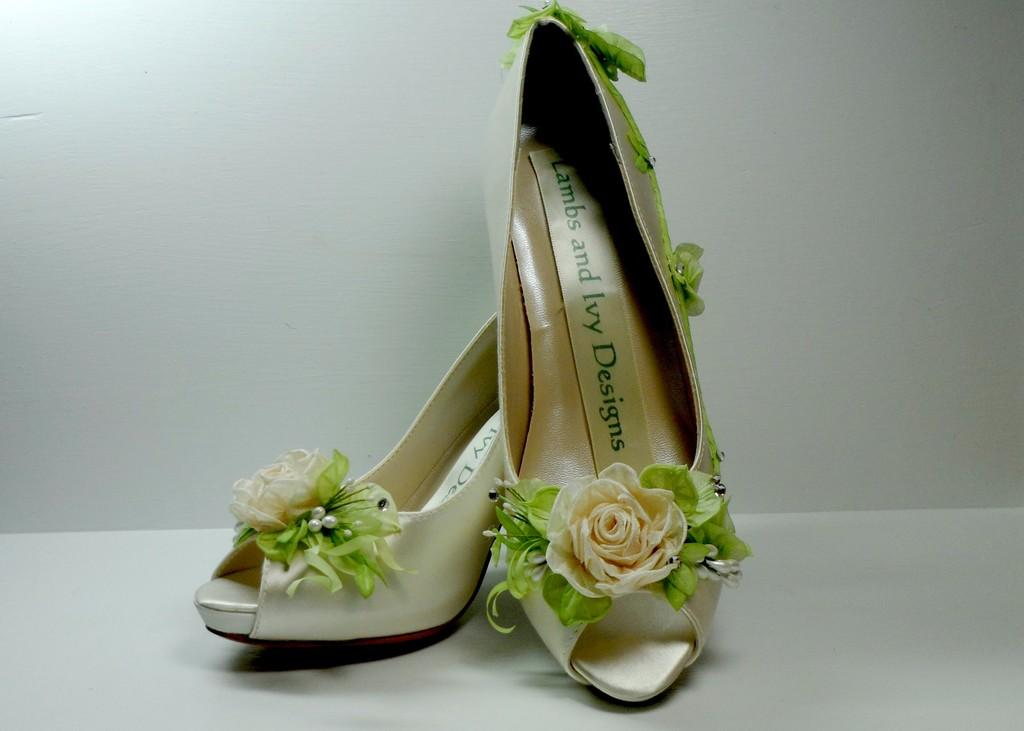What type of footwear is visible in the image? There are sandals in the image. Where are the sandals located? The sandals are placed on a surface. Reasoning: Let's think step by following the guidelines to produce the conversation. We start by identifying the main subject in the image, which is the sandals. Then, we describe their location, which is on a surface. We avoid yes/no questions and ensure that the language is simple and clear. Absurd Question/Answer: What direction are the police officers walking in the image? There are no police officers or any indication of direction in the image; it only features sandals placed on a surface. What type of balance exercise is being performed with the sandals in the image? There is no balance exercise or any indication of exercise in the image; it only features sandals placed on a surface. 